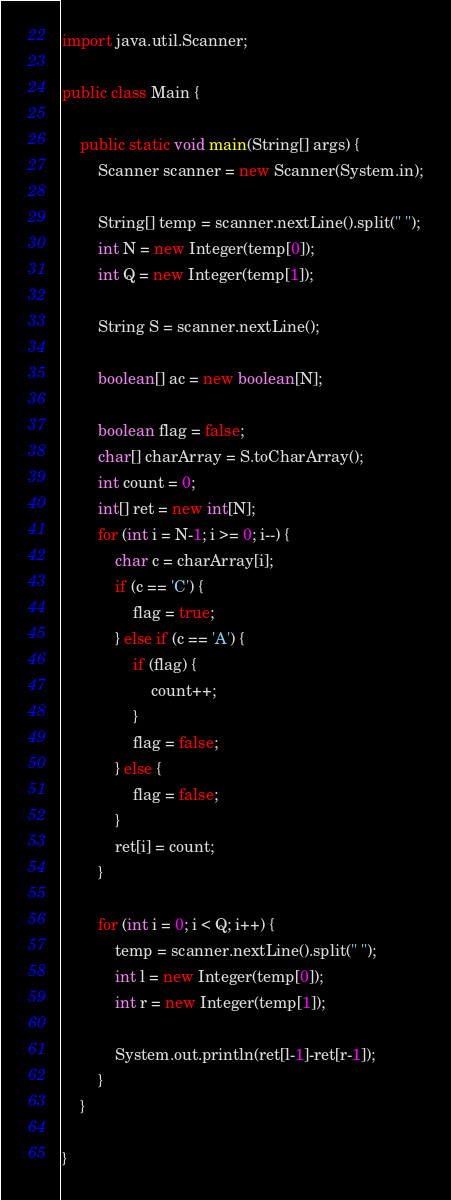Convert code to text. <code><loc_0><loc_0><loc_500><loc_500><_Java_>import java.util.Scanner;

public class Main {

    public static void main(String[] args) {
        Scanner scanner = new Scanner(System.in);

        String[] temp = scanner.nextLine().split(" ");
        int N = new Integer(temp[0]);
        int Q = new Integer(temp[1]);

        String S = scanner.nextLine();

        boolean[] ac = new boolean[N];

        boolean flag = false;
        char[] charArray = S.toCharArray();
        int count = 0;
        int[] ret = new int[N];
        for (int i = N-1; i >= 0; i--) {
            char c = charArray[i];
            if (c == 'C') {
                flag = true;
            } else if (c == 'A') {
                if (flag) {
                    count++;
                }
                flag = false;
            } else {
                flag = false;
            }
            ret[i] = count;
        }

        for (int i = 0; i < Q; i++) {
            temp = scanner.nextLine().split(" ");
            int l = new Integer(temp[0]);
            int r = new Integer(temp[1]);

            System.out.println(ret[l-1]-ret[r-1]);
        }
    }

}
</code> 